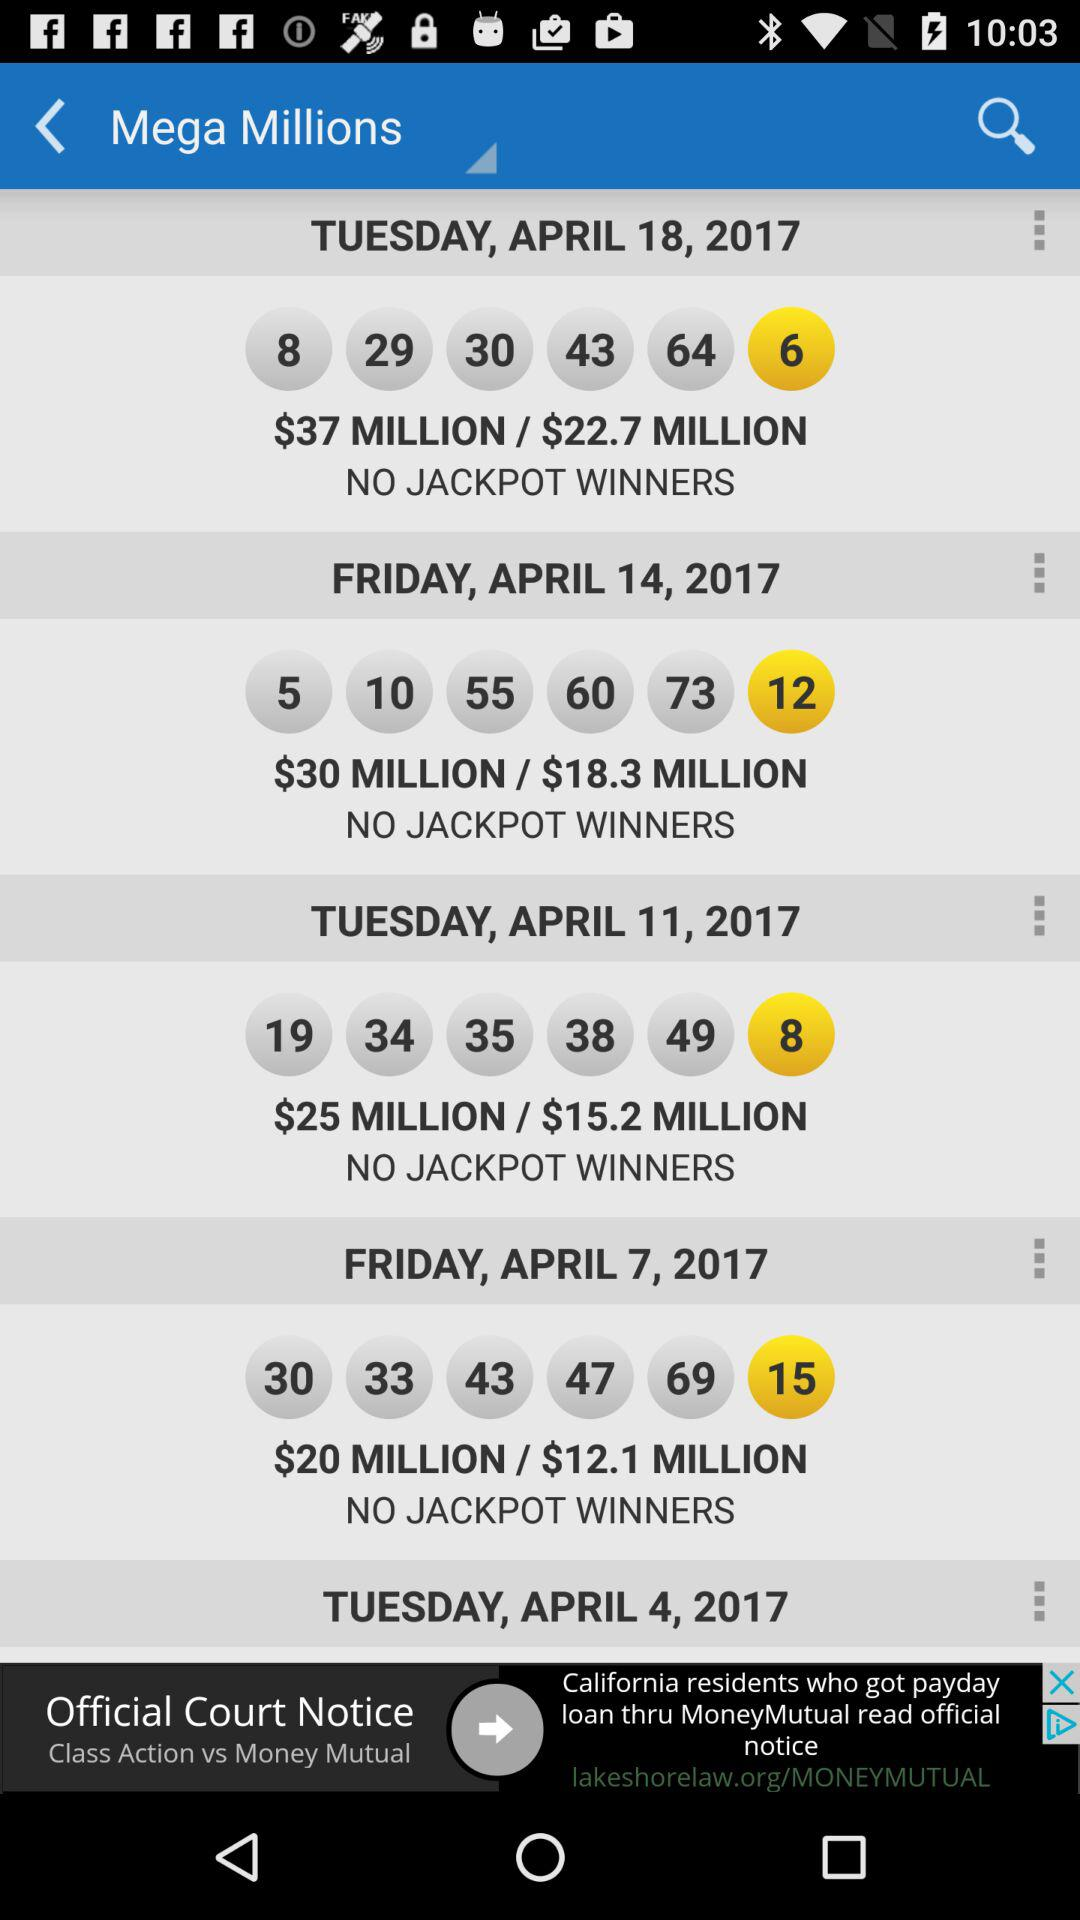How many drawings have jackpots over $20 million?
Answer the question using a single word or phrase. 3 